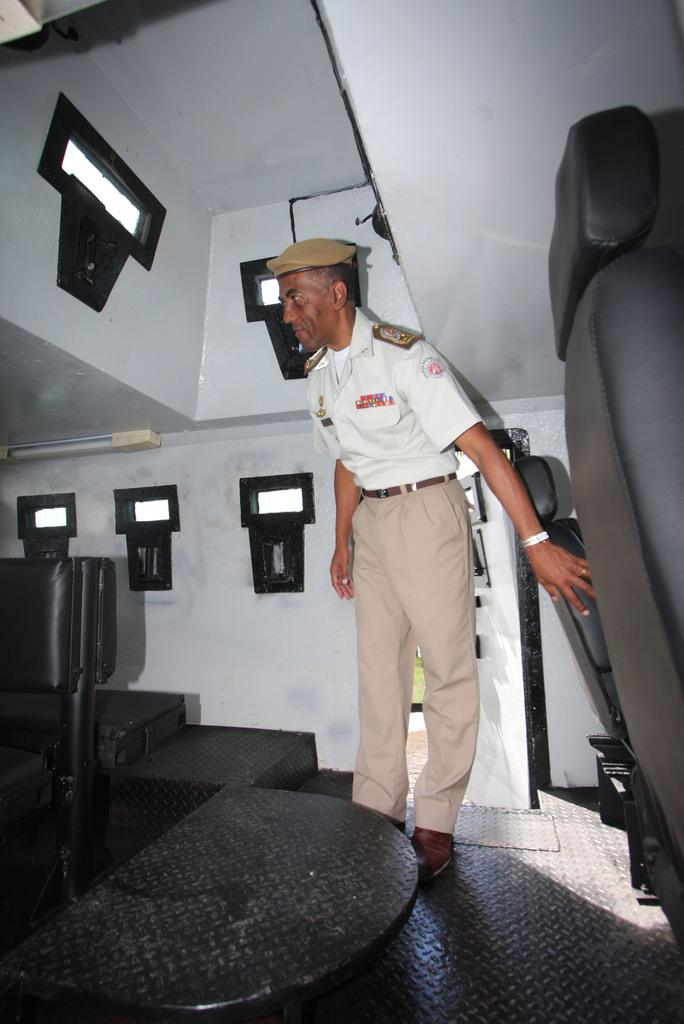What is the setting of the image? The image is taken inside a vehicle. What can be seen in the vehicle? There is a person standing beside the seats. What is the person wearing on their upper body? The person is wearing a white shirt. What type of headwear is the person wearing? The person is wearing a hat. What type of harmony can be heard in the image? There is no sound or music present in the image, so it is not possible to determine if there is any harmony. 